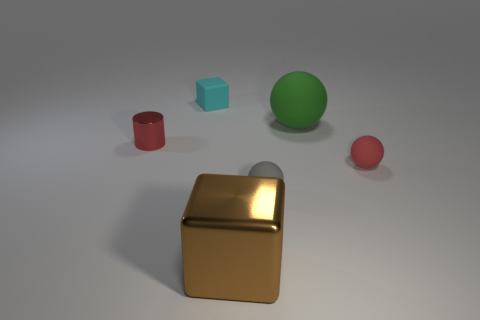Add 2 shiny blocks. How many objects exist? 8 Subtract all blocks. How many objects are left? 4 Subtract 1 red cylinders. How many objects are left? 5 Subtract all large green cylinders. Subtract all small rubber cubes. How many objects are left? 5 Add 2 gray objects. How many gray objects are left? 3 Add 5 tiny cyan rubber objects. How many tiny cyan rubber objects exist? 6 